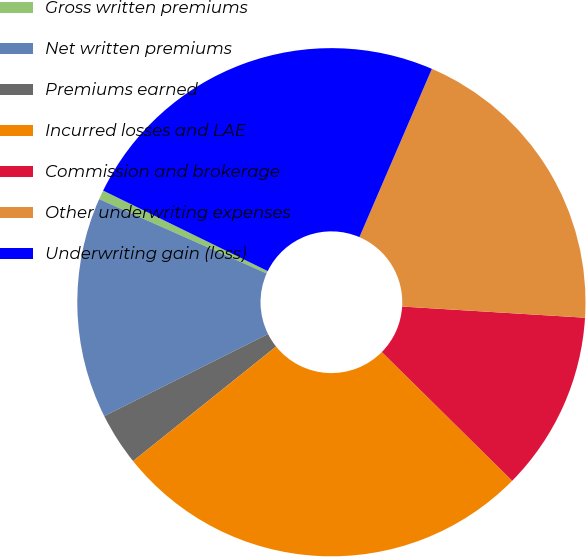Convert chart. <chart><loc_0><loc_0><loc_500><loc_500><pie_chart><fcel>Gross written premiums<fcel>Net written premiums<fcel>Premiums earned<fcel>Incurred losses and LAE<fcel>Commission and brokerage<fcel>Other underwriting expenses<fcel>Underwriting gain (loss)<nl><fcel>0.59%<fcel>14.05%<fcel>3.35%<fcel>26.85%<fcel>11.43%<fcel>19.5%<fcel>24.23%<nl></chart> 